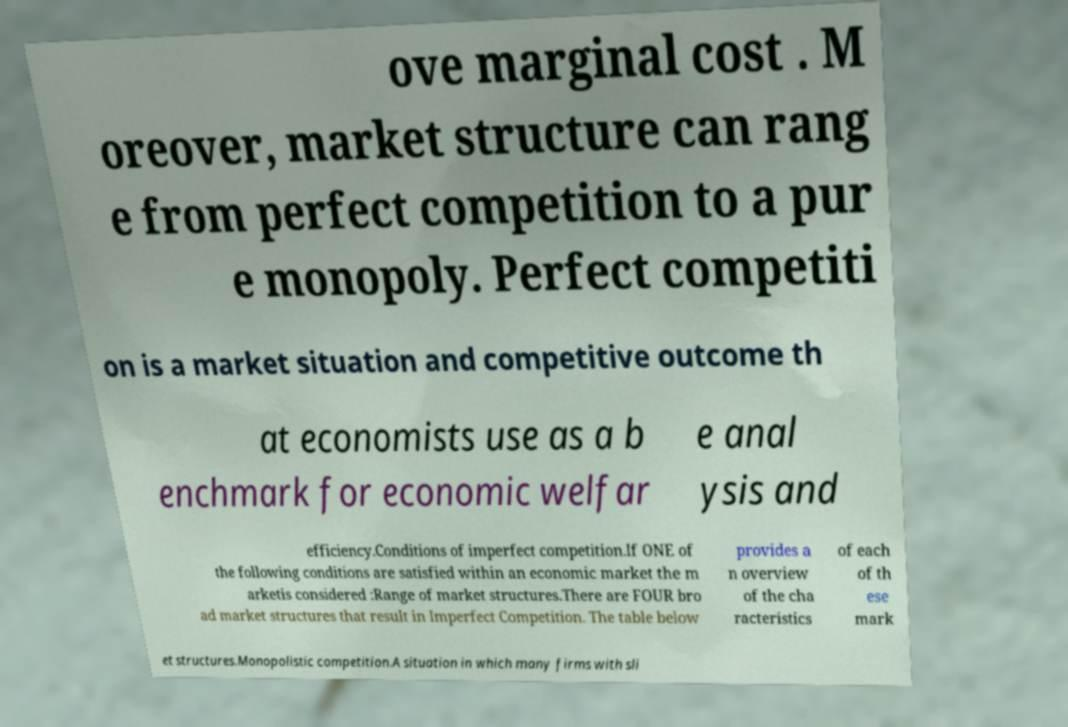What messages or text are displayed in this image? I need them in a readable, typed format. ove marginal cost . M oreover, market structure can rang e from perfect competition to a pur e monopoly. Perfect competiti on is a market situation and competitive outcome th at economists use as a b enchmark for economic welfar e anal ysis and efficiency.Conditions of imperfect competition.If ONE of the following conditions are satisfied within an economic market the m arketis considered :Range of market structures.There are FOUR bro ad market structures that result in Imperfect Competition. The table below provides a n overview of the cha racteristics of each of th ese mark et structures.Monopolistic competition.A situation in which many firms with sli 